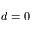<formula> <loc_0><loc_0><loc_500><loc_500>d = 0</formula> 